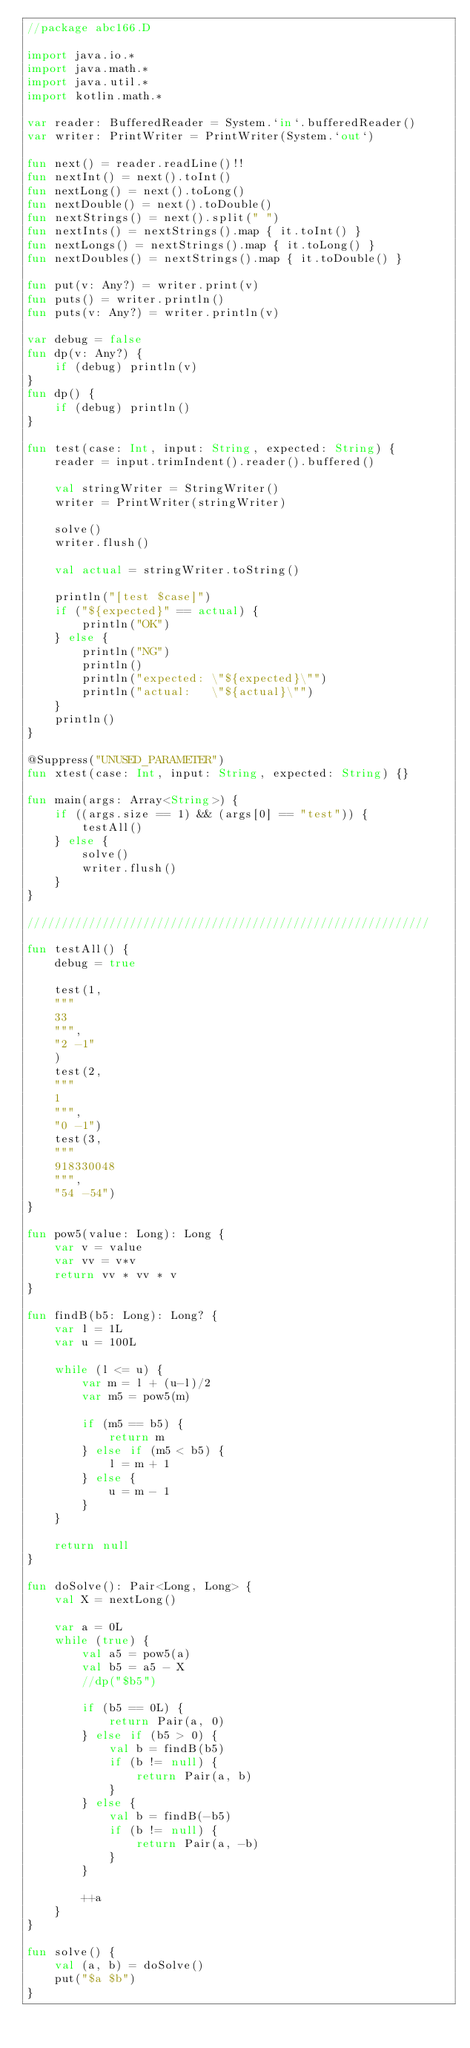Convert code to text. <code><loc_0><loc_0><loc_500><loc_500><_Kotlin_>//package abc166.D

import java.io.*
import java.math.*
import java.util.*
import kotlin.math.*

var reader: BufferedReader = System.`in`.bufferedReader()
var writer: PrintWriter = PrintWriter(System.`out`)

fun next() = reader.readLine()!!
fun nextInt() = next().toInt()
fun nextLong() = next().toLong()
fun nextDouble() = next().toDouble()
fun nextStrings() = next().split(" ")
fun nextInts() = nextStrings().map { it.toInt() }
fun nextLongs() = nextStrings().map { it.toLong() }
fun nextDoubles() = nextStrings().map { it.toDouble() }

fun put(v: Any?) = writer.print(v)
fun puts() = writer.println()
fun puts(v: Any?) = writer.println(v)

var debug = false
fun dp(v: Any?) {
    if (debug) println(v)
}
fun dp() {
    if (debug) println()
}

fun test(case: Int, input: String, expected: String) {
    reader = input.trimIndent().reader().buffered()

    val stringWriter = StringWriter()
    writer = PrintWriter(stringWriter)

    solve()
    writer.flush()

    val actual = stringWriter.toString()

    println("[test $case]")
    if ("${expected}" == actual) {
        println("OK")
    } else {
        println("NG")
        println()
        println("expected: \"${expected}\"")
        println("actual:   \"${actual}\"")
    }
    println()
}

@Suppress("UNUSED_PARAMETER")
fun xtest(case: Int, input: String, expected: String) {}

fun main(args: Array<String>) {
    if ((args.size == 1) && (args[0] == "test")) {
        testAll()
    } else {
        solve()
        writer.flush()
    }
}

///////////////////////////////////////////////////////////

fun testAll() {
    debug = true

    test(1,
    """
    33
    """,
    "2 -1"
    )
    test(2,
    """
    1
    """,
    "0 -1")
    test(3,
    """
    918330048
    """,
    "54 -54")
}

fun pow5(value: Long): Long {
    var v = value
    var vv = v*v
    return vv * vv * v
}

fun findB(b5: Long): Long? {
    var l = 1L
    var u = 100L

    while (l <= u) {
        var m = l + (u-l)/2
        var m5 = pow5(m)

        if (m5 == b5) {
            return m
        } else if (m5 < b5) {
            l = m + 1
        } else {
            u = m - 1
        }
    }

    return null
}

fun doSolve(): Pair<Long, Long> {
    val X = nextLong()

    var a = 0L
    while (true) {
        val a5 = pow5(a)
        val b5 = a5 - X
        //dp("$b5")

        if (b5 == 0L) {
            return Pair(a, 0)
        } else if (b5 > 0) {
            val b = findB(b5)
            if (b != null) {
                return Pair(a, b)
            }
        } else {
            val b = findB(-b5)
            if (b != null) {
                return Pair(a, -b)
            }
        }

        ++a
    }
}

fun solve() {
    val (a, b) = doSolve()
    put("$a $b")
}
</code> 